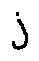<formula> <loc_0><loc_0><loc_500><loc_500>j</formula> 